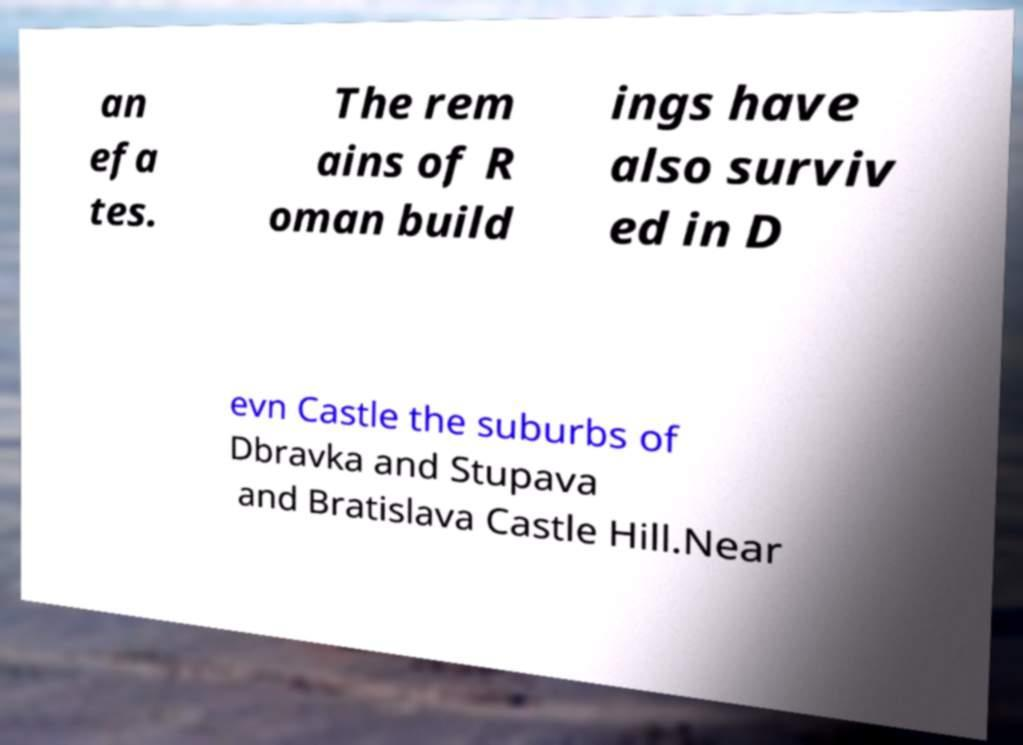I need the written content from this picture converted into text. Can you do that? an efa tes. The rem ains of R oman build ings have also surviv ed in D evn Castle the suburbs of Dbravka and Stupava and Bratislava Castle Hill.Near 